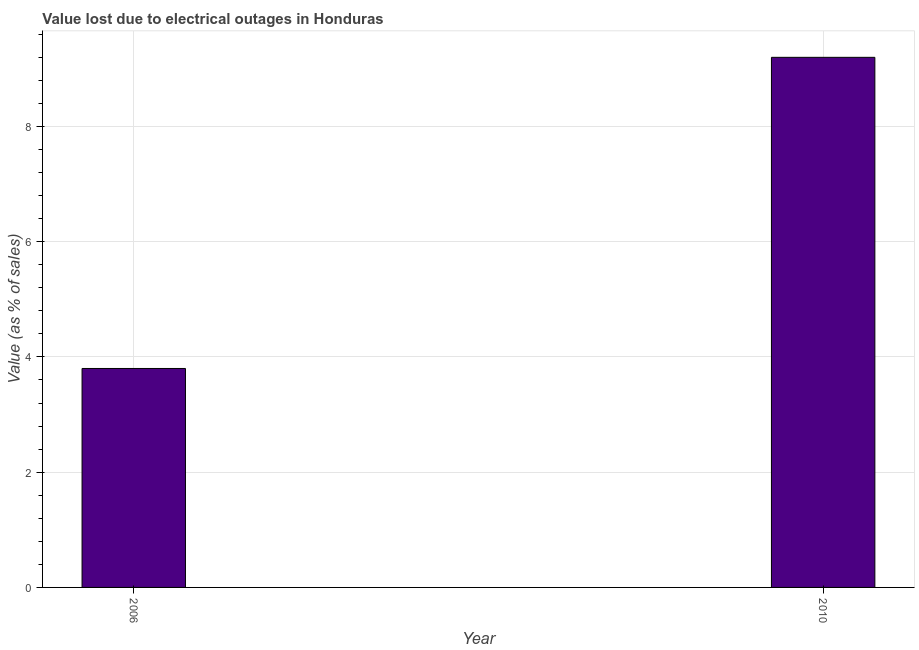What is the title of the graph?
Ensure brevity in your answer.  Value lost due to electrical outages in Honduras. What is the label or title of the X-axis?
Your response must be concise. Year. What is the label or title of the Y-axis?
Give a very brief answer. Value (as % of sales). What is the value lost due to electrical outages in 2006?
Your answer should be very brief. 3.8. In which year was the value lost due to electrical outages minimum?
Give a very brief answer. 2006. What is the sum of the value lost due to electrical outages?
Provide a succinct answer. 13. What is the difference between the value lost due to electrical outages in 2006 and 2010?
Give a very brief answer. -5.4. What is the average value lost due to electrical outages per year?
Keep it short and to the point. 6.5. What is the median value lost due to electrical outages?
Your answer should be compact. 6.5. What is the ratio of the value lost due to electrical outages in 2006 to that in 2010?
Keep it short and to the point. 0.41. In how many years, is the value lost due to electrical outages greater than the average value lost due to electrical outages taken over all years?
Provide a succinct answer. 1. How many bars are there?
Make the answer very short. 2. Are the values on the major ticks of Y-axis written in scientific E-notation?
Provide a succinct answer. No. What is the ratio of the Value (as % of sales) in 2006 to that in 2010?
Offer a terse response. 0.41. 